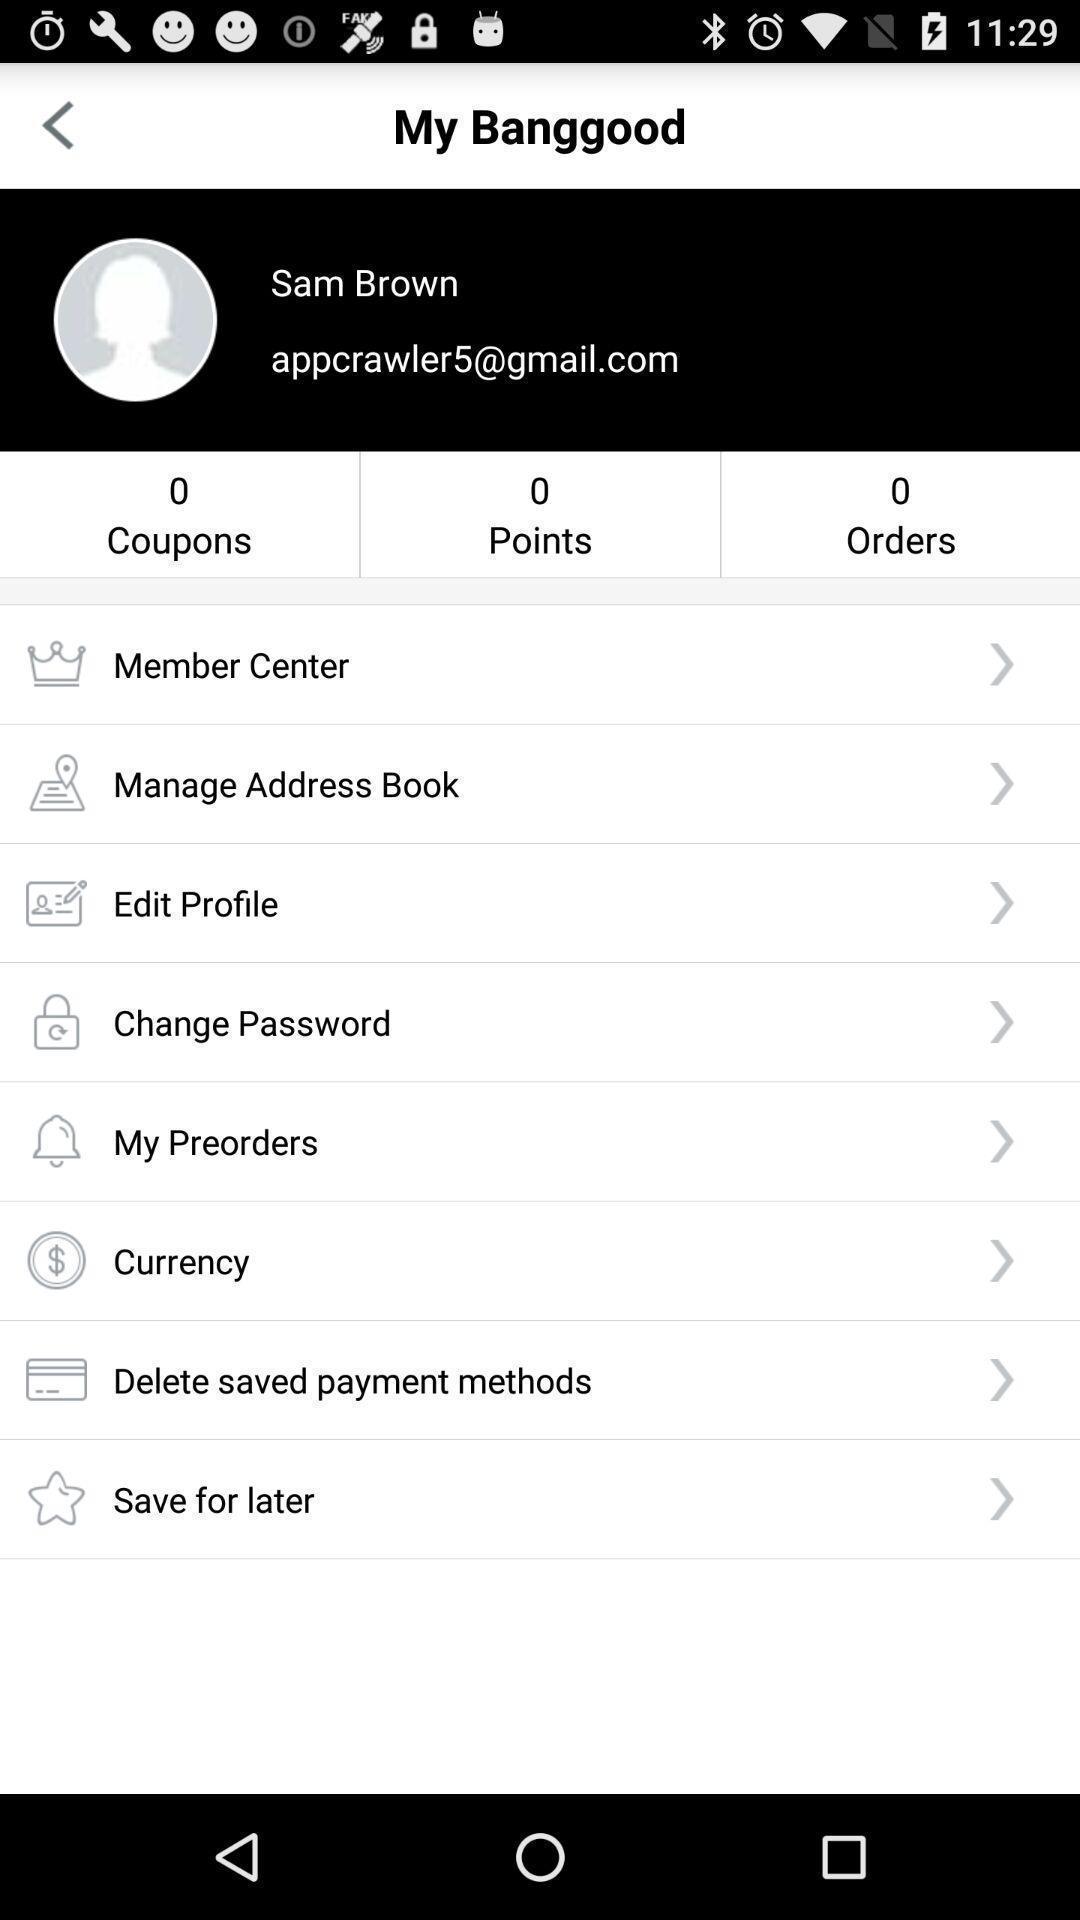Tell me what you see in this picture. Profile page. 